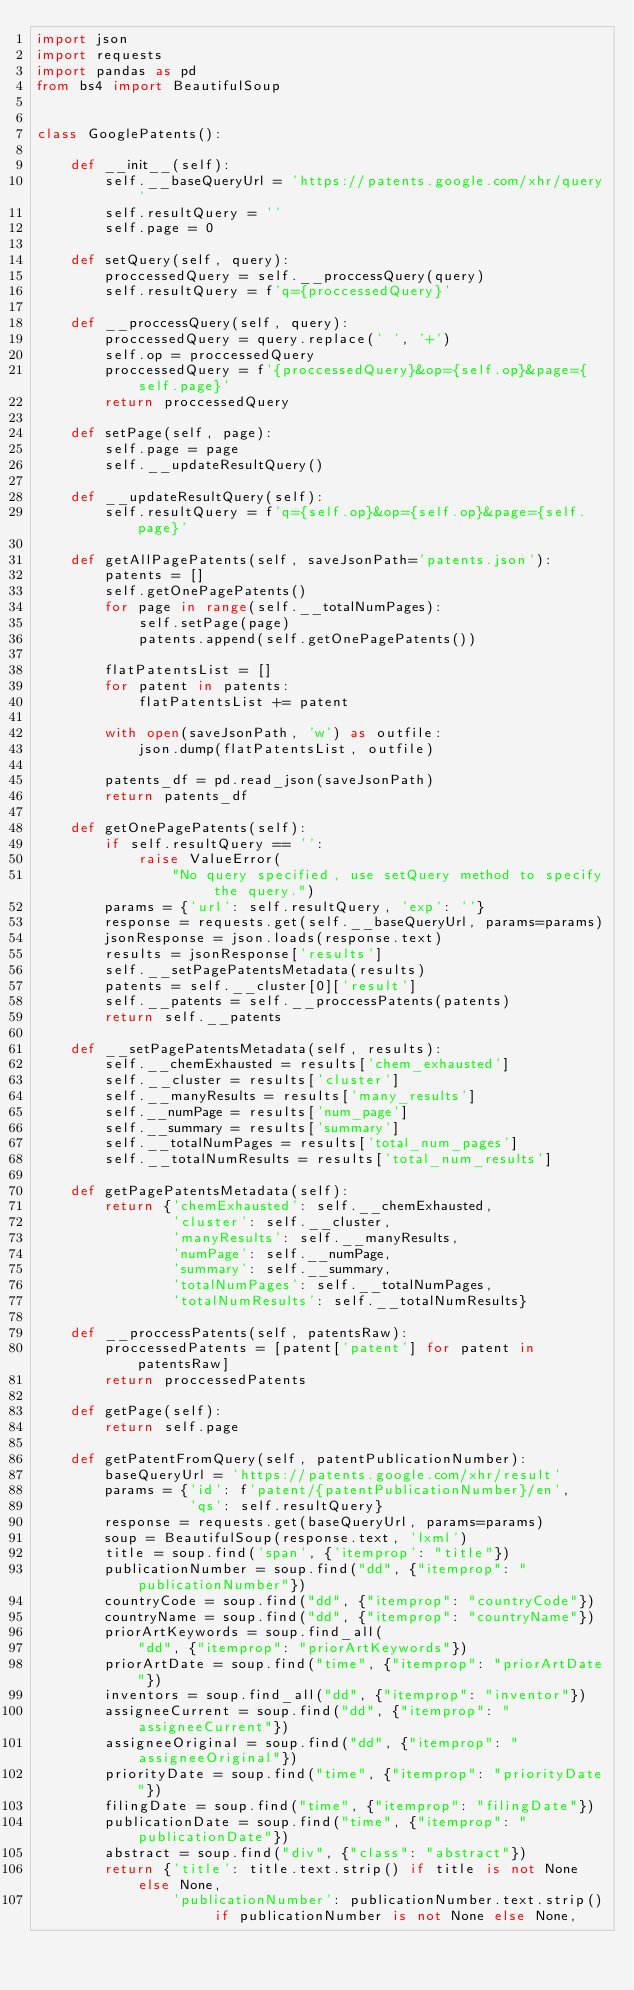<code> <loc_0><loc_0><loc_500><loc_500><_Python_>import json
import requests
import pandas as pd
from bs4 import BeautifulSoup


class GooglePatents():

    def __init__(self):
        self.__baseQueryUrl = 'https://patents.google.com/xhr/query'
        self.resultQuery = ''
        self.page = 0

    def setQuery(self, query):
        proccessedQuery = self.__proccessQuery(query)
        self.resultQuery = f'q={proccessedQuery}'

    def __proccessQuery(self, query):
        proccessedQuery = query.replace(' ', '+')
        self.op = proccessedQuery
        proccessedQuery = f'{proccessedQuery}&op={self.op}&page={self.page}'
        return proccessedQuery

    def setPage(self, page):
        self.page = page
        self.__updateResultQuery()

    def __updateResultQuery(self):
        self.resultQuery = f'q={self.op}&op={self.op}&page={self.page}'

    def getAllPagePatents(self, saveJsonPath='patents.json'):
        patents = []
        self.getOnePagePatents()
        for page in range(self.__totalNumPages):
            self.setPage(page)
            patents.append(self.getOnePagePatents())

        flatPatentsList = []
        for patent in patents:
            flatPatentsList += patent

        with open(saveJsonPath, 'w') as outfile:
            json.dump(flatPatentsList, outfile)

        patents_df = pd.read_json(saveJsonPath)
        return patents_df

    def getOnePagePatents(self):
        if self.resultQuery == '':
            raise ValueError(
                "No query specified, use setQuery method to specify the query.")
        params = {'url': self.resultQuery, 'exp': ''}
        response = requests.get(self.__baseQueryUrl, params=params)
        jsonResponse = json.loads(response.text)
        results = jsonResponse['results']
        self.__setPagePatentsMetadata(results)
        patents = self.__cluster[0]['result']
        self.__patents = self.__proccessPatents(patents)
        return self.__patents

    def __setPagePatentsMetadata(self, results):
        self.__chemExhausted = results['chem_exhausted']
        self.__cluster = results['cluster']
        self.__manyResults = results['many_results']
        self.__numPage = results['num_page']
        self.__summary = results['summary']
        self.__totalNumPages = results['total_num_pages']
        self.__totalNumResults = results['total_num_results']

    def getPagePatentsMetadata(self):
        return {'chemExhausted': self.__chemExhausted,
                'cluster': self.__cluster,
                'manyResults': self.__manyResults,
                'numPage': self.__numPage,
                'summary': self.__summary,
                'totalNumPages': self.__totalNumPages,
                'totalNumResults': self.__totalNumResults}

    def __proccessPatents(self, patentsRaw):
        proccessedPatents = [patent['patent'] for patent in patentsRaw]
        return proccessedPatents

    def getPage(self):
        return self.page

    def getPatentFromQuery(self, patentPublicationNumber):
        baseQueryUrl = 'https://patents.google.com/xhr/result'
        params = {'id': f'patent/{patentPublicationNumber}/en',
                  'qs': self.resultQuery}
        response = requests.get(baseQueryUrl, params=params)
        soup = BeautifulSoup(response.text, 'lxml')
        title = soup.find('span', {'itemprop': "title"})
        publicationNumber = soup.find("dd", {"itemprop": "publicationNumber"})
        countryCode = soup.find("dd", {"itemprop": "countryCode"})
        countryName = soup.find("dd", {"itemprop": "countryName"})
        priorArtKeywords = soup.find_all(
            "dd", {"itemprop": "priorArtKeywords"})
        priorArtDate = soup.find("time", {"itemprop": "priorArtDate"})
        inventors = soup.find_all("dd", {"itemprop": "inventor"})
        assigneeCurrent = soup.find("dd", {"itemprop": "assigneeCurrent"})
        assigneeOriginal = soup.find("dd", {"itemprop": "assigneeOriginal"})
        priorityDate = soup.find("time", {"itemprop": "priorityDate"})
        filingDate = soup.find("time", {"itemprop": "filingDate"})
        publicationDate = soup.find("time", {"itemprop": "publicationDate"})
        abstract = soup.find("div", {"class": "abstract"})
        return {'title': title.text.strip() if title is not None else None,
                'publicationNumber': publicationNumber.text.strip() if publicationNumber is not None else None,</code> 